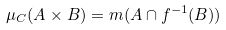<formula> <loc_0><loc_0><loc_500><loc_500>\mu _ { C } ( A \times B ) = m ( A \cap f ^ { - 1 } ( B ) )</formula> 